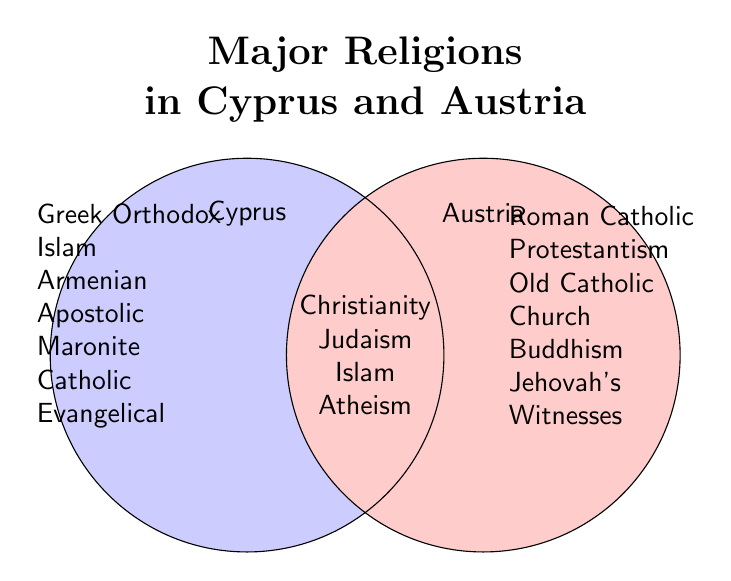What is the title of the figure? The top of the figure contains a text in bold and large font which is the title of the Venn Diagram.
Answer: Major Religions in Cyprus and Austria What religions are common to both Cyprus and Austria? The central overlapping area of the Venn Diagram lists the religions common to both countries.
Answer: Christianity, Judaism, Islam, Atheism How many religions are exclusive to Cyprus? The left circle representing Cyprus lists the exclusive religions. Count these items.
Answer: 5 How many religions are listed for Austria? Both the exclusive and the common religions need to be counted. Count the exclusive religions in the right circle, then add the count of common religions.
Answer: 9 Which country has more exclusive religions, Cyprus or Austria? Count the exclusive religions in each circle and compare. Cyprus has 5, and Austria has 5.
Answer: Neither (both have 5) Among the common religions, which one also appears in Cyprus's exclusive list? Identify if any religion listed in the common area also appears exclusively in Cyprus's side.
Answer: Islam Is Protestantism present in Cyprus? Check the Cyprus's exclusive list and common list to see if Protestantism is mentioned.
Answer: No How many religions are unique to Austria, not shared with Cyprus? Count the religions listed exclusively in the Austria section of the Venn Diagram.
Answer: 5 What is the intersection (common part) of the religious groups in Cyprus and Austria? Look at the center overlapping area of the Venn Diagram. This lists all religions common to both.
Answer: Christianity, Judaism, Islam, Atheism 